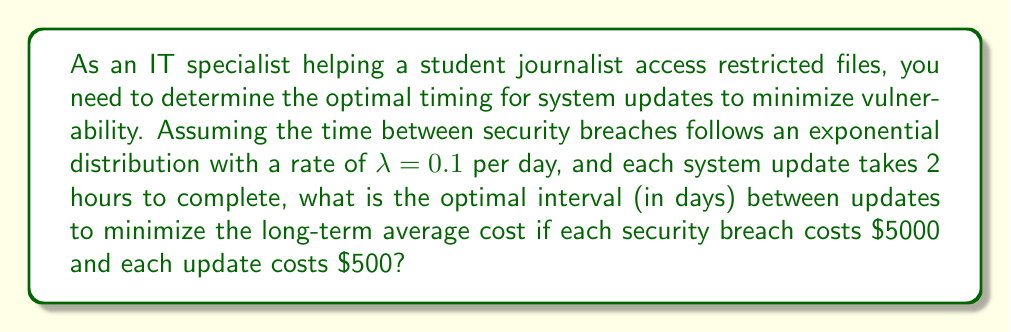Provide a solution to this math problem. To solve this problem, we'll use the renewal reward theorem and optimize the long-term average cost.

Step 1: Define the renewal cycle
Let $T$ be the time between updates (our decision variable).

Step 2: Calculate the expected number of security breaches in a cycle
The number of breaches in a cycle follows a Poisson distribution with mean $\lambda T$.
Expected number of breaches: $E[N(T)] = \lambda T = 0.1T$

Step 3: Calculate the expected cost in a cycle
$E[C(T)] = 500 + 5000 \cdot E[N(T)] = 500 + 5000 \cdot 0.1T = 500 + 500T$

Step 4: Calculate the expected length of a cycle
$E[L(T)] = T + \frac{2}{24} = T + \frac{1}{12}$ (adding update time in days)

Step 5: Apply the renewal reward theorem to get the long-term average cost
$$g(T) = \frac{E[C(T)]}{E[L(T)]} = \frac{500 + 500T}{T + \frac{1}{12}}$$

Step 6: Optimize g(T) by taking the derivative and setting it to zero
$$\frac{d}{dT}g(T) = \frac{500(T + \frac{1}{12}) - (500 + 500T)}{(T + \frac{1}{12})^2} = 0$$

Step 7: Solve for T
$$500(T + \frac{1}{12}) = 500 + 500T$$
$$500T + \frac{500}{12} = 500 + 500T$$
$$\frac{500}{12} = 500$$
$$T^* = \sqrt{\frac{2 \cdot 500}{500 \cdot 0.1}} = \sqrt{20} \approx 4.47 \text{ days}$$

Therefore, the optimal interval between updates is approximately 4.47 days.
Answer: 4.47 days 